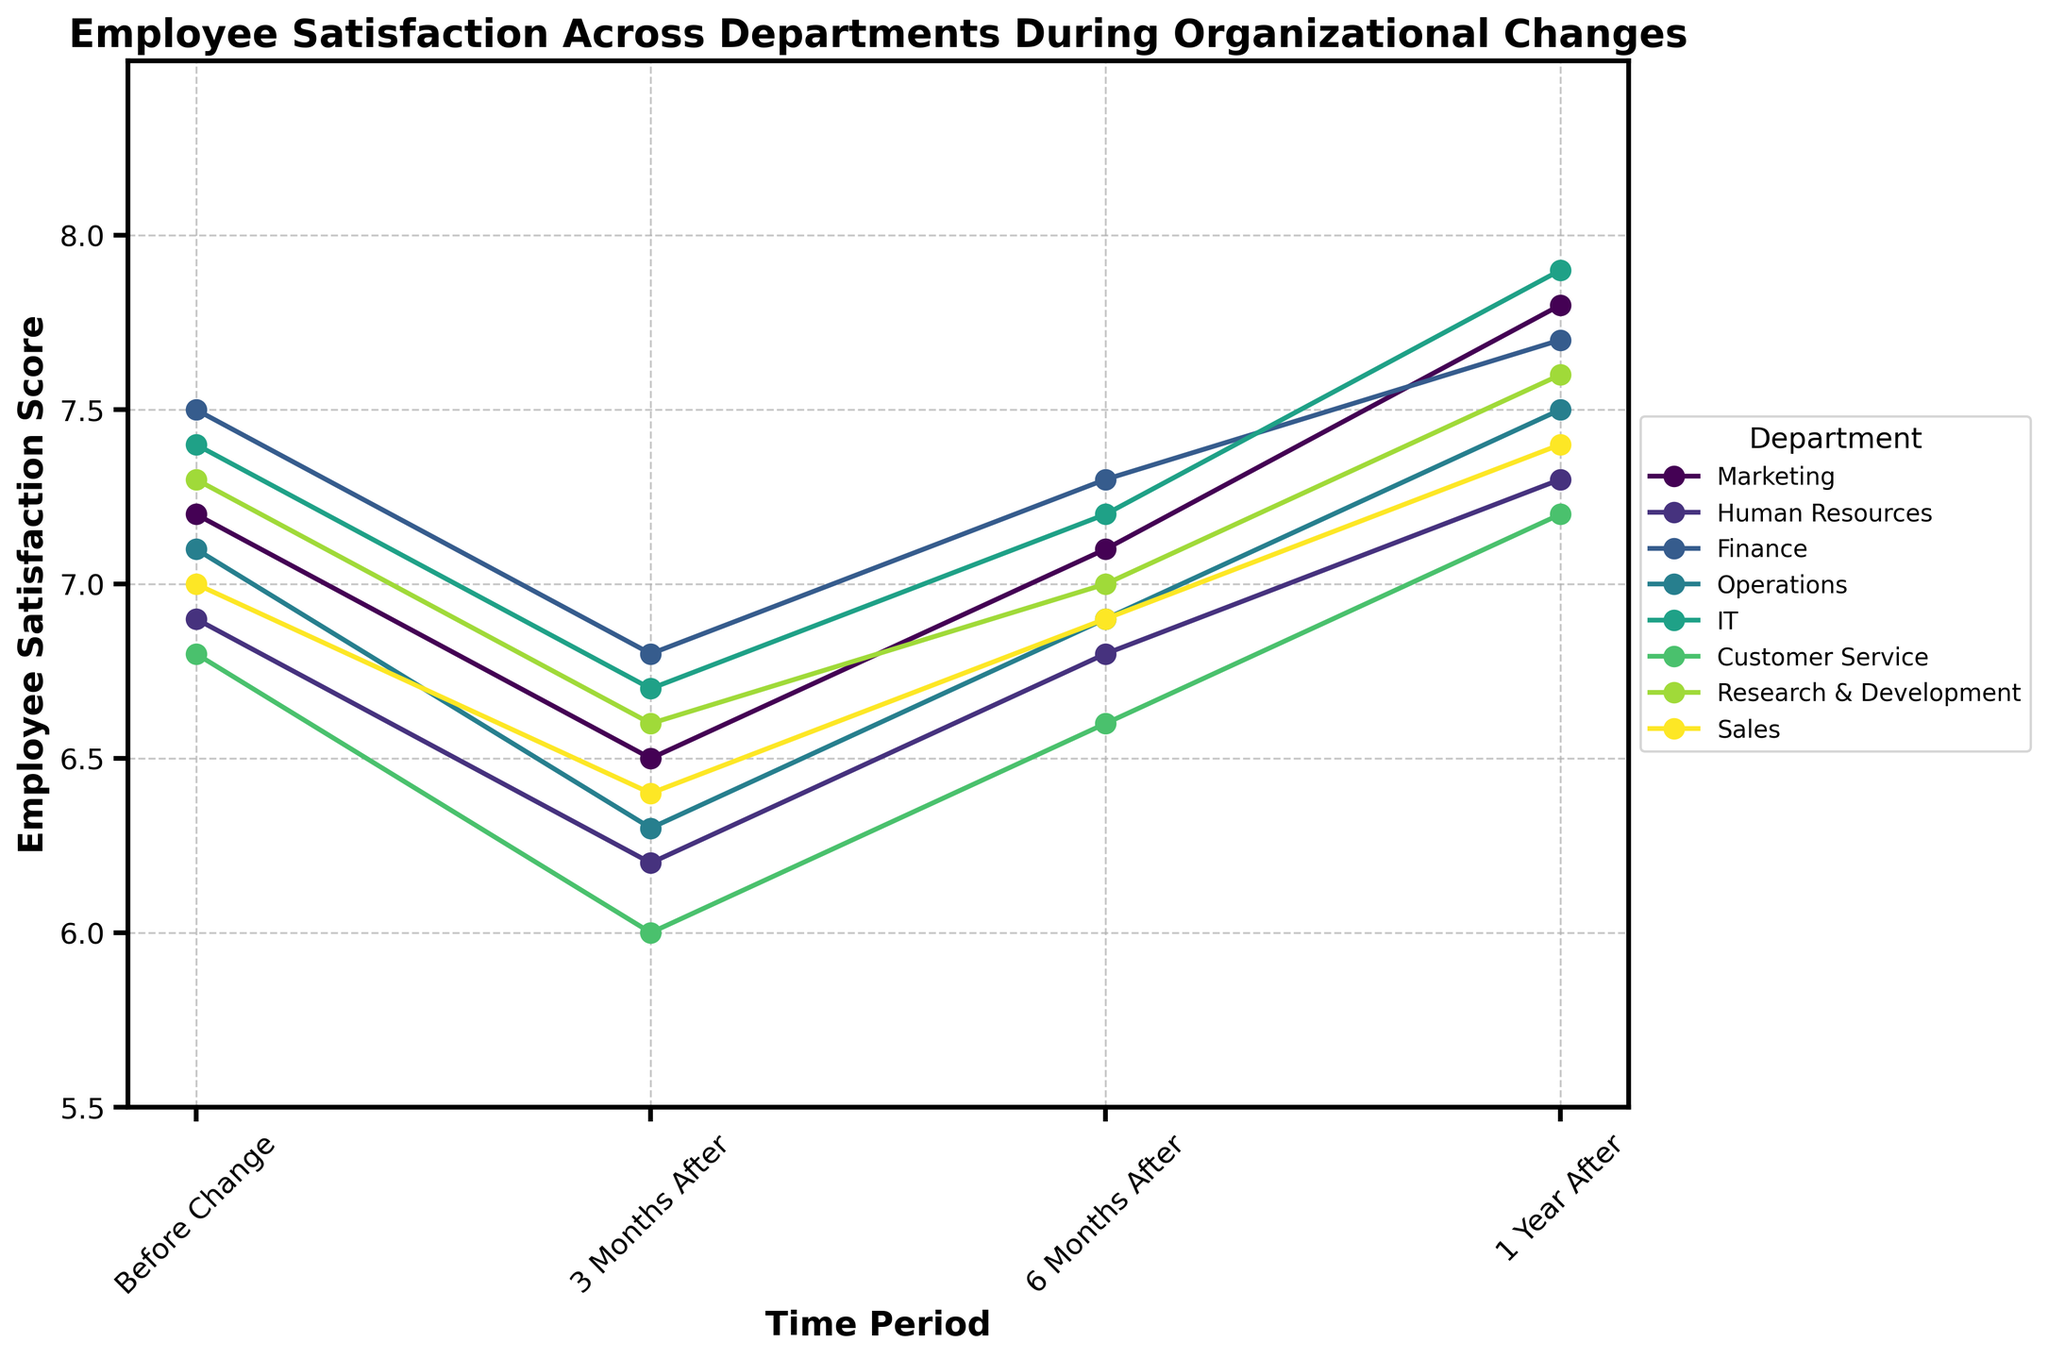What is the title of the plot? The title of the plot is displayed prominently at the top and provides an overview of what the visual represents.
Answer: Employee Satisfaction Across Departments During Organizational Changes Which department has the highest employee satisfaction score one year after the change? By comparing the employee satisfaction scores of all departments one year after the change on the plot, the department with the highest score can be identified.
Answer: IT On average, how did employee satisfaction scores change across all departments from before the change to six months after the change? To find the average change, subtract the six-month scores from the before-change scores for each department, sum the differences, and then divide by the number of departments.
Answer: -0.3 Which departments showed an increase in employee satisfaction from 6 months after the change to 1 year after the change? Examine the trend lines for each department between the 6-month and 1-year points. Identify departments where the employee satisfaction scores increased.
Answer: All departments Which department had the most significant drop in employee satisfaction 3 months after the change? To find this, compare the drop in employee satisfaction scores from before the change to 3 months after for each department. The largest drop signifies the most significant decrease.
Answer: Customer Service Between the Finance and Sales departments, which one showed a greater improvement in employee satisfaction from 6 months after the change to 1 year after the change? By comparing the improvement in scores between these periods for both the Finance and Sales departments, the one with the larger increase can be identified.
Answer: Finance What is the range of employee satisfaction scores for the Operations department throughout the four time periods? To find the range, note the lowest and highest satisfaction scores for Operations across all time periods and subtract the smallest from the largest.
Answer: 6.3 to 7.5 Which department had the least variation in employee satisfaction scores across all time periods? Calculate the range (difference between highest and lowest scores) for each department. The department with the smallest range has the least variation.
Answer: Marketing Considering only the initial period, which departments had satisfaction scores lower than 7? Look at the satisfaction scores 'Before Change' and identify which ones are below 7.
Answer: Human Resources, Customer Service, Sales 